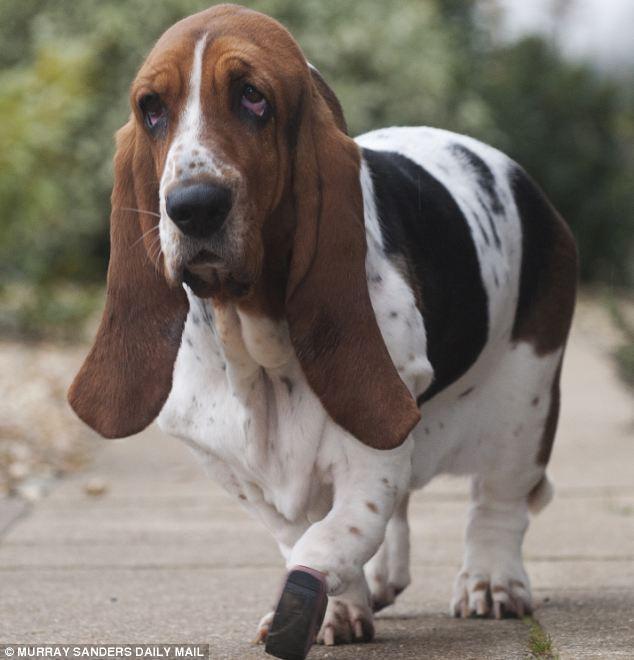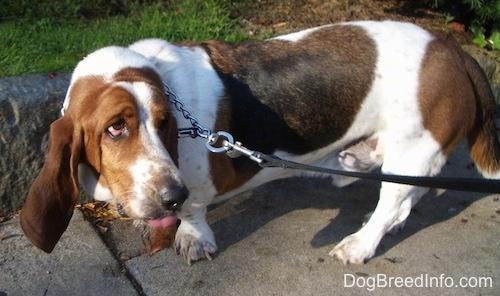The first image is the image on the left, the second image is the image on the right. Evaluate the accuracy of this statement regarding the images: "Two basset hounds face the camera and are not standing on grass.". Is it true? Answer yes or no. No. The first image is the image on the left, the second image is the image on the right. For the images displayed, is the sentence "At least one dog is standing on grass." factually correct? Answer yes or no. No. 